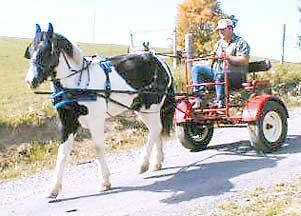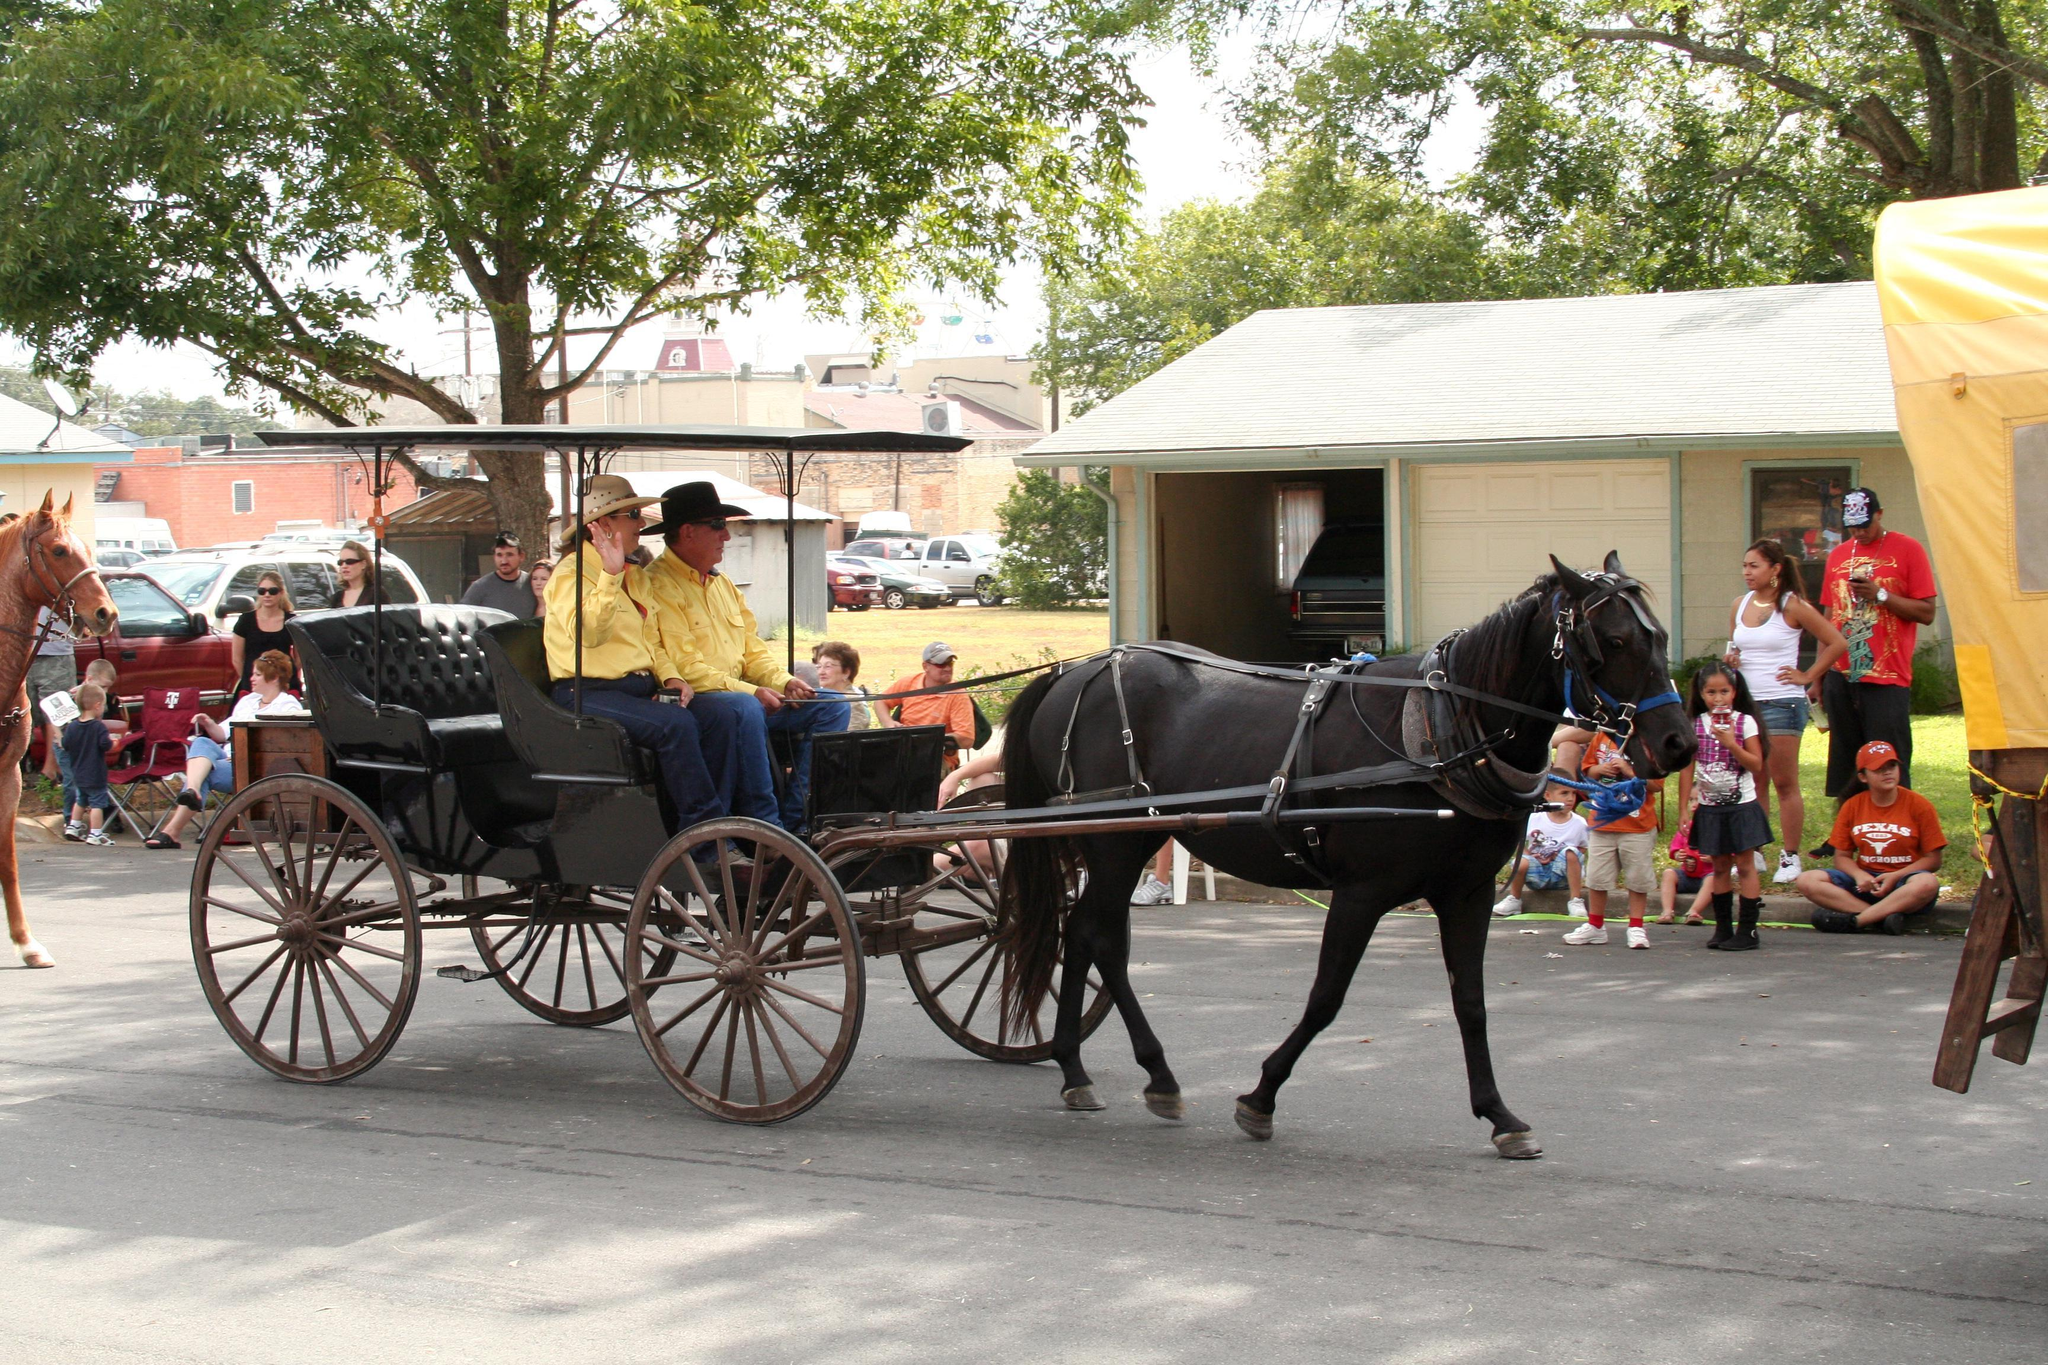The first image is the image on the left, the second image is the image on the right. Analyze the images presented: Is the assertion "One image shows an empty cart parked in front of a garage door." valid? Answer yes or no. No. The first image is the image on the left, the second image is the image on the right. Analyze the images presented: Is the assertion "there is a black horse in the image on the right" valid? Answer yes or no. Yes. 